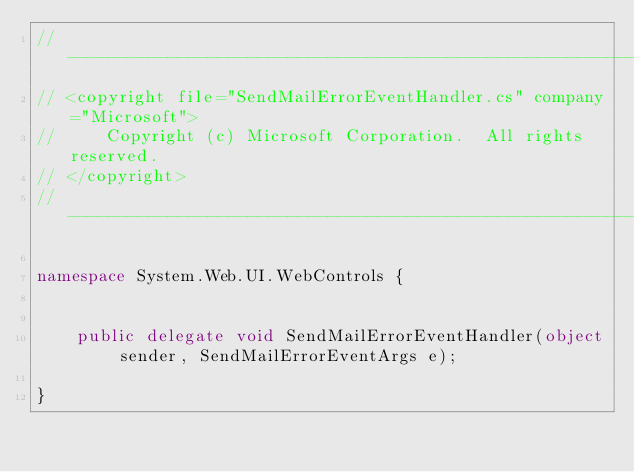<code> <loc_0><loc_0><loc_500><loc_500><_C#_>//------------------------------------------------------------------------------
// <copyright file="SendMailErrorEventHandler.cs" company="Microsoft">
//     Copyright (c) Microsoft Corporation.  All rights reserved.
// </copyright>
//------------------------------------------------------------------------------

namespace System.Web.UI.WebControls {


    public delegate void SendMailErrorEventHandler(object sender, SendMailErrorEventArgs e);

}
</code> 